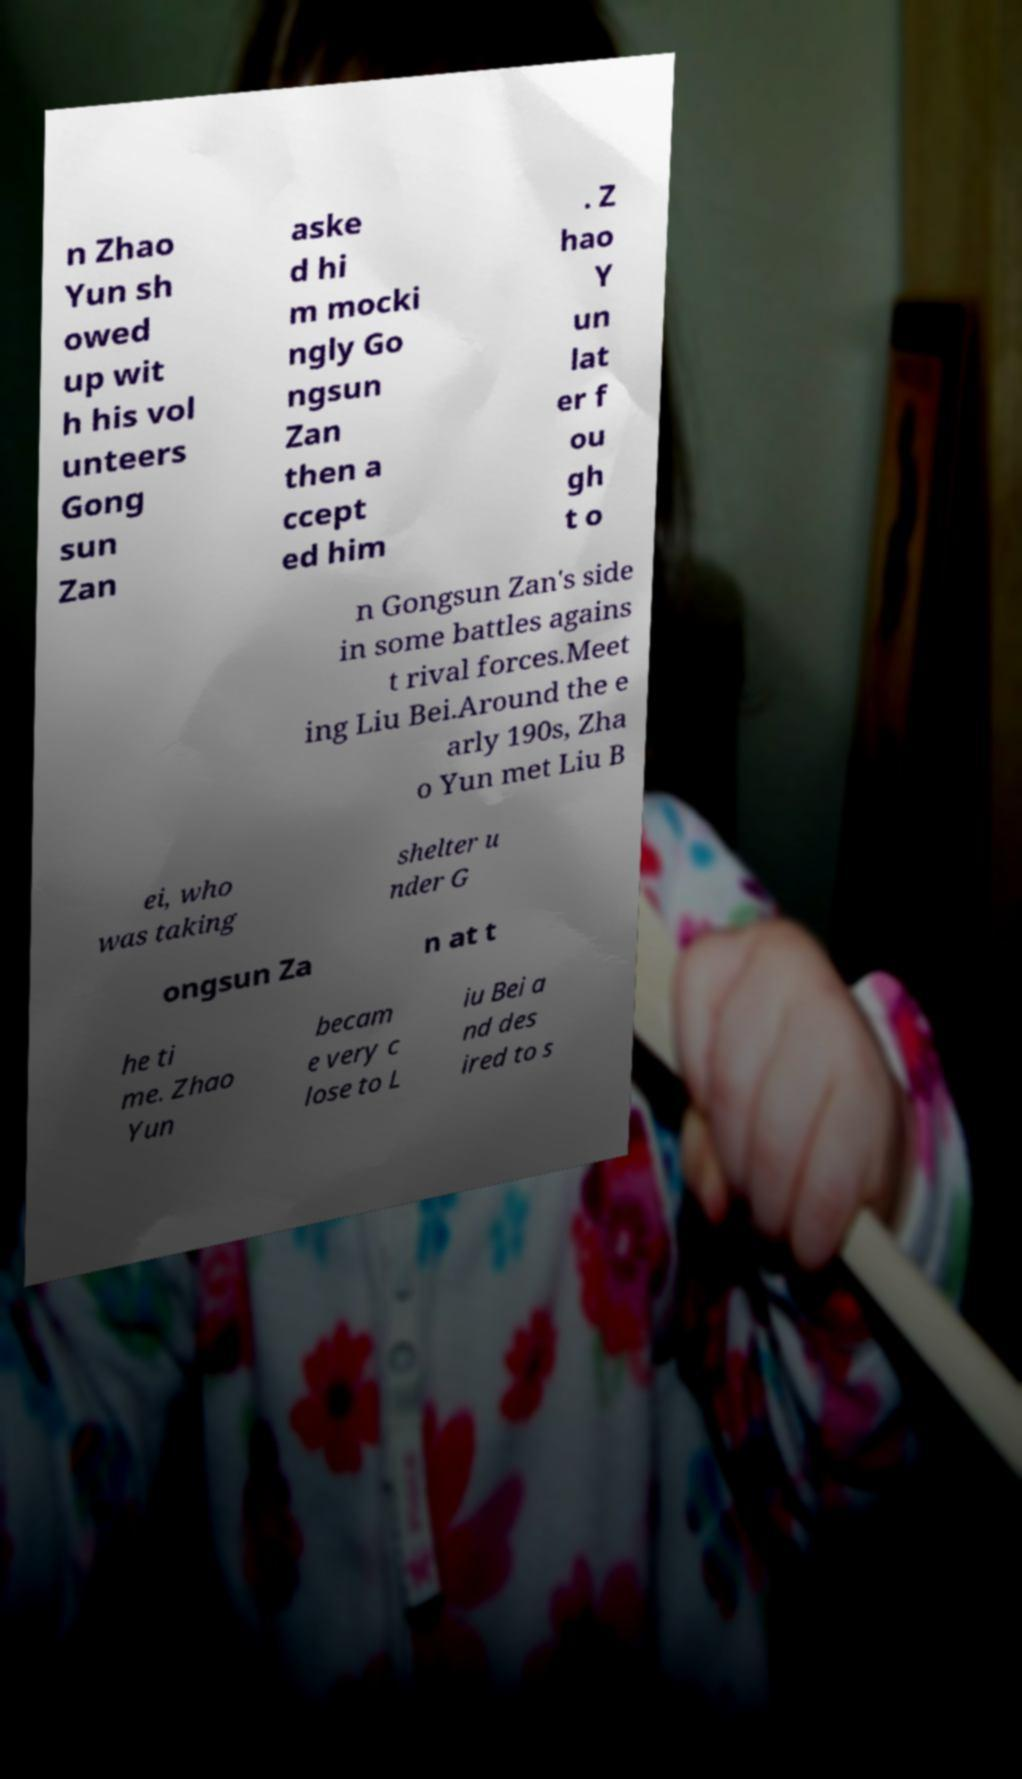Could you extract and type out the text from this image? n Zhao Yun sh owed up wit h his vol unteers Gong sun Zan aske d hi m mocki ngly Go ngsun Zan then a ccept ed him . Z hao Y un lat er f ou gh t o n Gongsun Zan's side in some battles agains t rival forces.Meet ing Liu Bei.Around the e arly 190s, Zha o Yun met Liu B ei, who was taking shelter u nder G ongsun Za n at t he ti me. Zhao Yun becam e very c lose to L iu Bei a nd des ired to s 